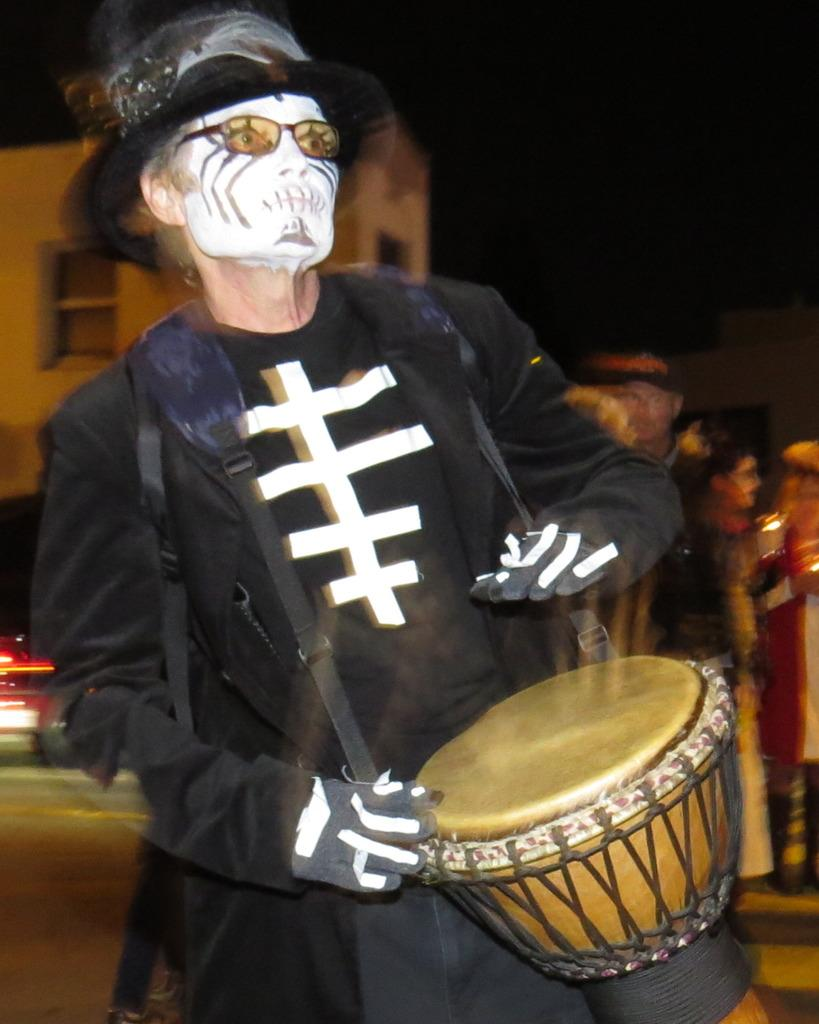What can be seen in the image? There is a person in the image. Can you describe the appearance of the person? The person has white makeup and is wearing a black costume. What else is present in the image? There is a musical instrument hanging in the image. What type of celery is being used as a prop in the image? There is no celery present in the image. How many stitches are visible on the person's costume in the image? The provided facts do not mention any stitches on the person's costume, so it cannot be determined from the image. 